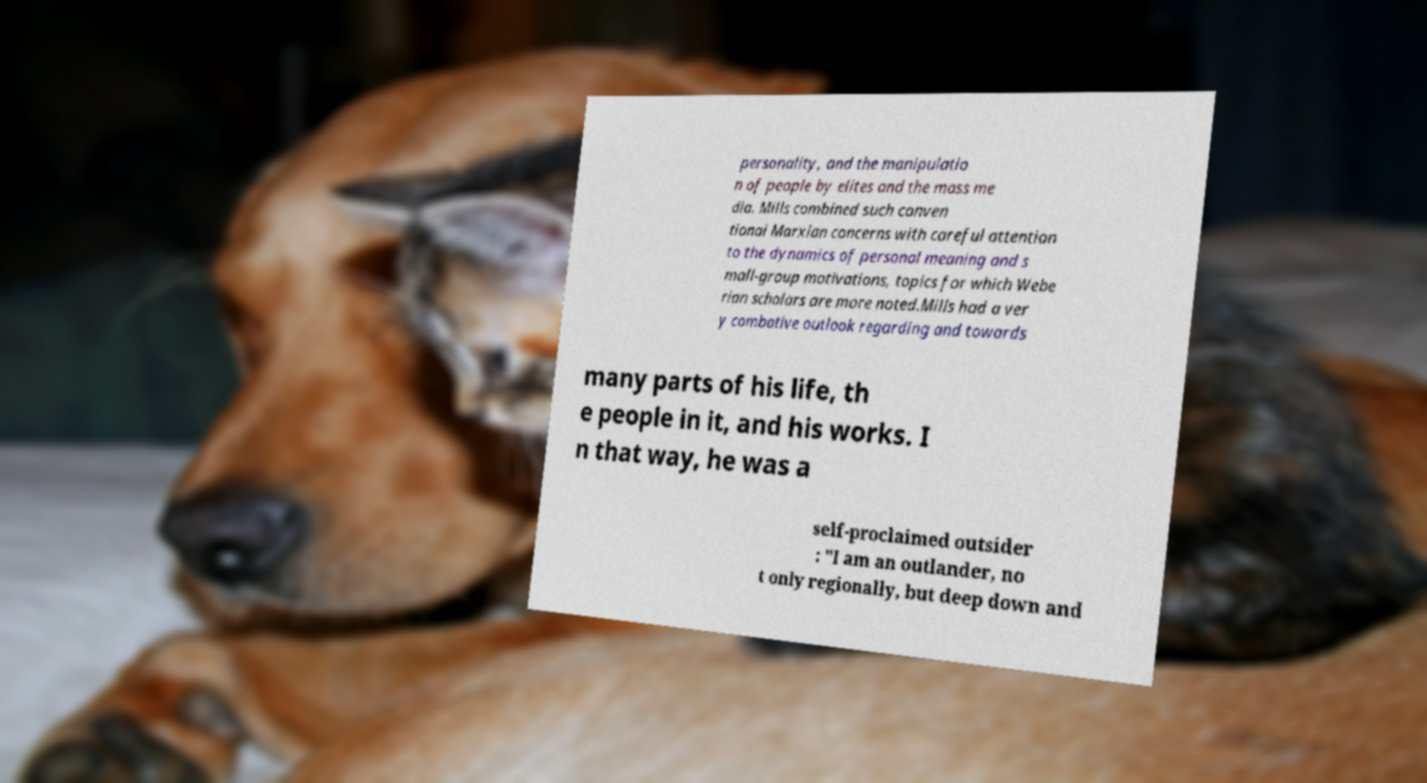Can you read and provide the text displayed in the image?This photo seems to have some interesting text. Can you extract and type it out for me? personality, and the manipulatio n of people by elites and the mass me dia. Mills combined such conven tional Marxian concerns with careful attention to the dynamics of personal meaning and s mall-group motivations, topics for which Webe rian scholars are more noted.Mills had a ver y combative outlook regarding and towards many parts of his life, th e people in it, and his works. I n that way, he was a self-proclaimed outsider : "I am an outlander, no t only regionally, but deep down and 